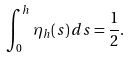<formula> <loc_0><loc_0><loc_500><loc_500>\int _ { 0 } ^ { h } { \eta _ { h } ( s ) \, d s } = \frac { 1 } { 2 } .</formula> 